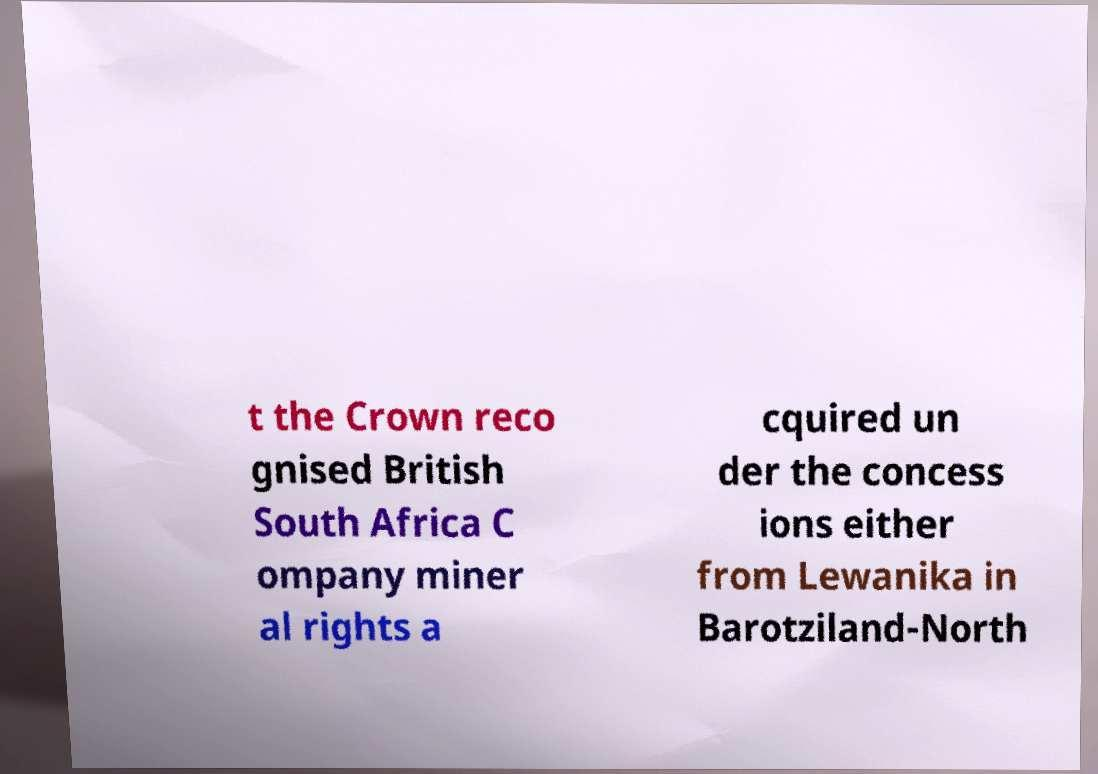Please read and relay the text visible in this image. What does it say? t the Crown reco gnised British South Africa C ompany miner al rights a cquired un der the concess ions either from Lewanika in Barotziland-North 